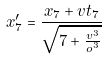<formula> <loc_0><loc_0><loc_500><loc_500>x _ { 7 } ^ { \prime } = \frac { x _ { 7 } + v t _ { 7 } } { \sqrt { 7 + \frac { v ^ { 3 } } { o ^ { 3 } } } }</formula> 